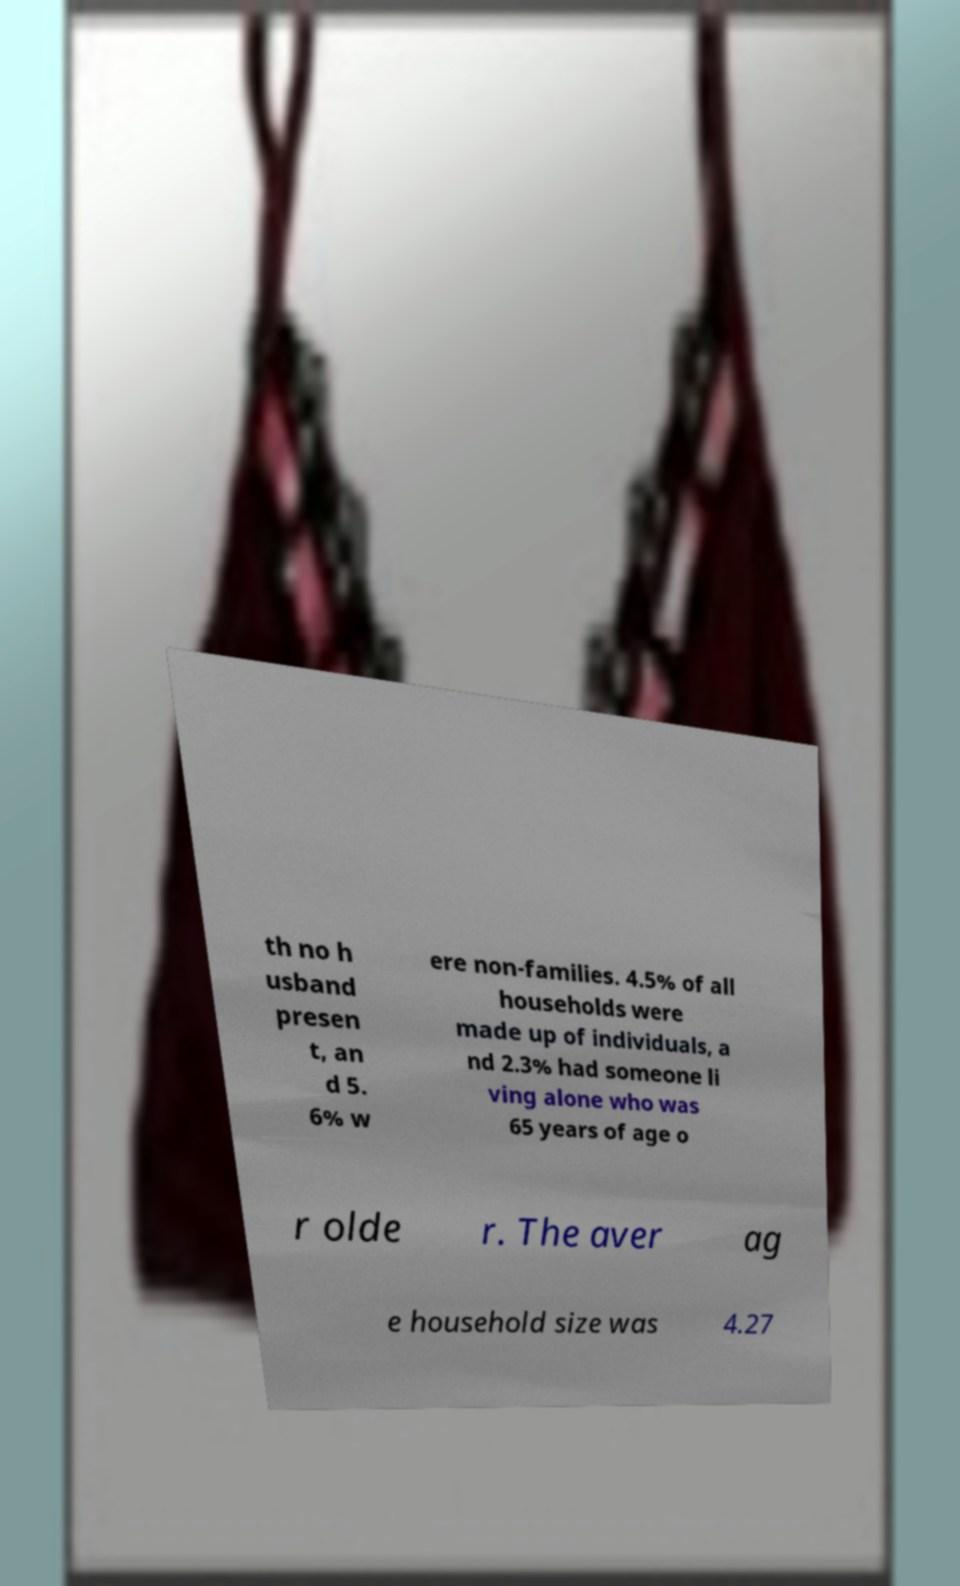There's text embedded in this image that I need extracted. Can you transcribe it verbatim? th no h usband presen t, an d 5. 6% w ere non-families. 4.5% of all households were made up of individuals, a nd 2.3% had someone li ving alone who was 65 years of age o r olde r. The aver ag e household size was 4.27 